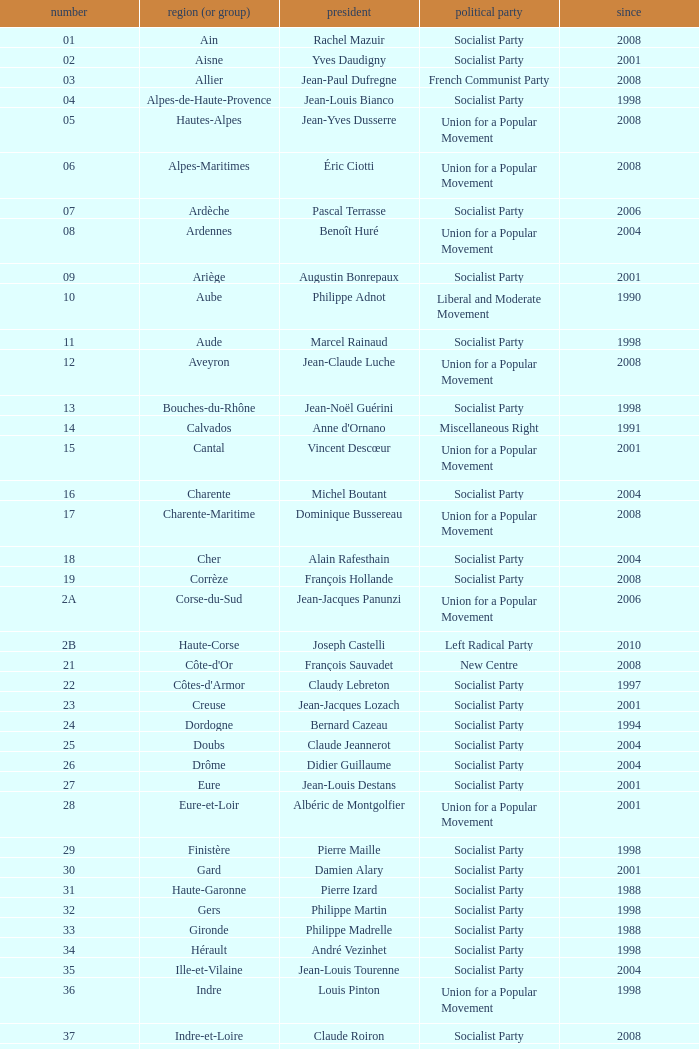Who is the president from the Union for a Popular Movement party that represents the Hautes-Alpes department? Jean-Yves Dusserre. 